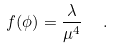Convert formula to latex. <formula><loc_0><loc_0><loc_500><loc_500>f ( \phi ) = \frac { \lambda } { \mu ^ { 4 } } \ \ .</formula> 